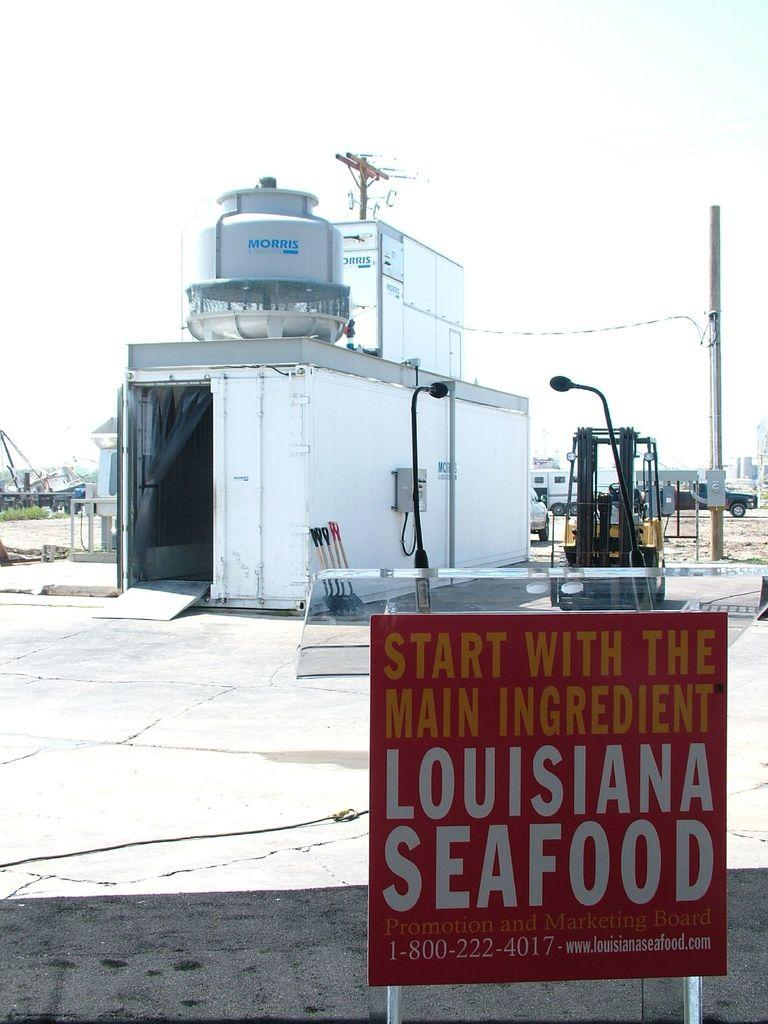<image>
Offer a succinct explanation of the picture presented. A sign advertising Louisiana seafood has a phone number at the bottom of it. 